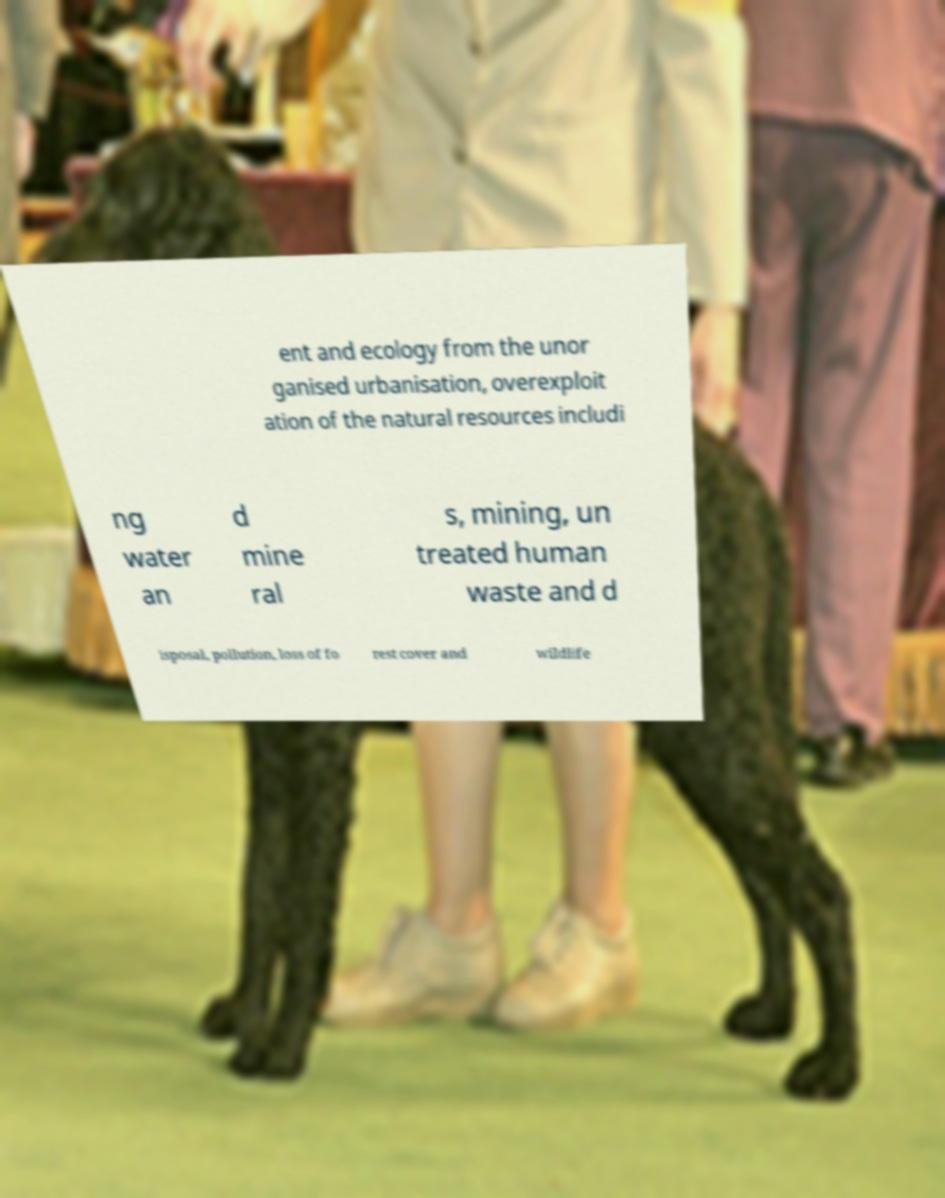Please identify and transcribe the text found in this image. ent and ecology from the unor ganised urbanisation, overexploit ation of the natural resources includi ng water an d mine ral s, mining, un treated human waste and d isposal, pollution, loss of fo rest cover and wildlife 